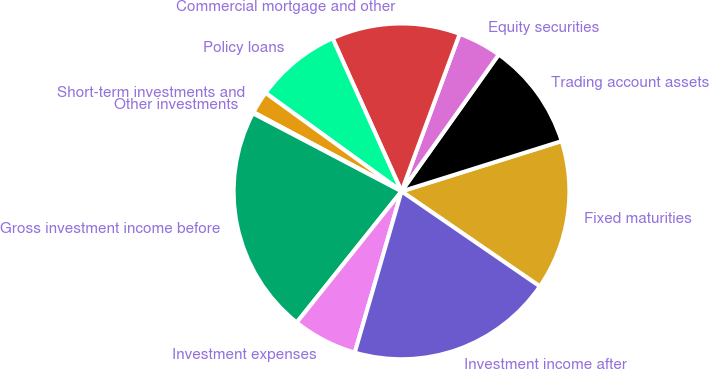Convert chart to OTSL. <chart><loc_0><loc_0><loc_500><loc_500><pie_chart><fcel>Fixed maturities<fcel>Trading account assets<fcel>Equity securities<fcel>Commercial mortgage and other<fcel>Policy loans<fcel>Short-term investments and<fcel>Other investments<fcel>Gross investment income before<fcel>Investment expenses<fcel>Investment income after<nl><fcel>14.42%<fcel>10.33%<fcel>4.2%<fcel>12.37%<fcel>8.29%<fcel>2.16%<fcel>0.12%<fcel>21.96%<fcel>6.24%<fcel>19.91%<nl></chart> 